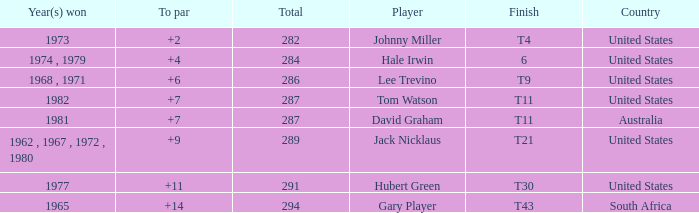WHAT IS THE TOTAL THAT HAS A WIN IN 1982? 287.0. 